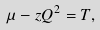Convert formula to latex. <formula><loc_0><loc_0><loc_500><loc_500>\mu - z Q ^ { 2 } = T ,</formula> 